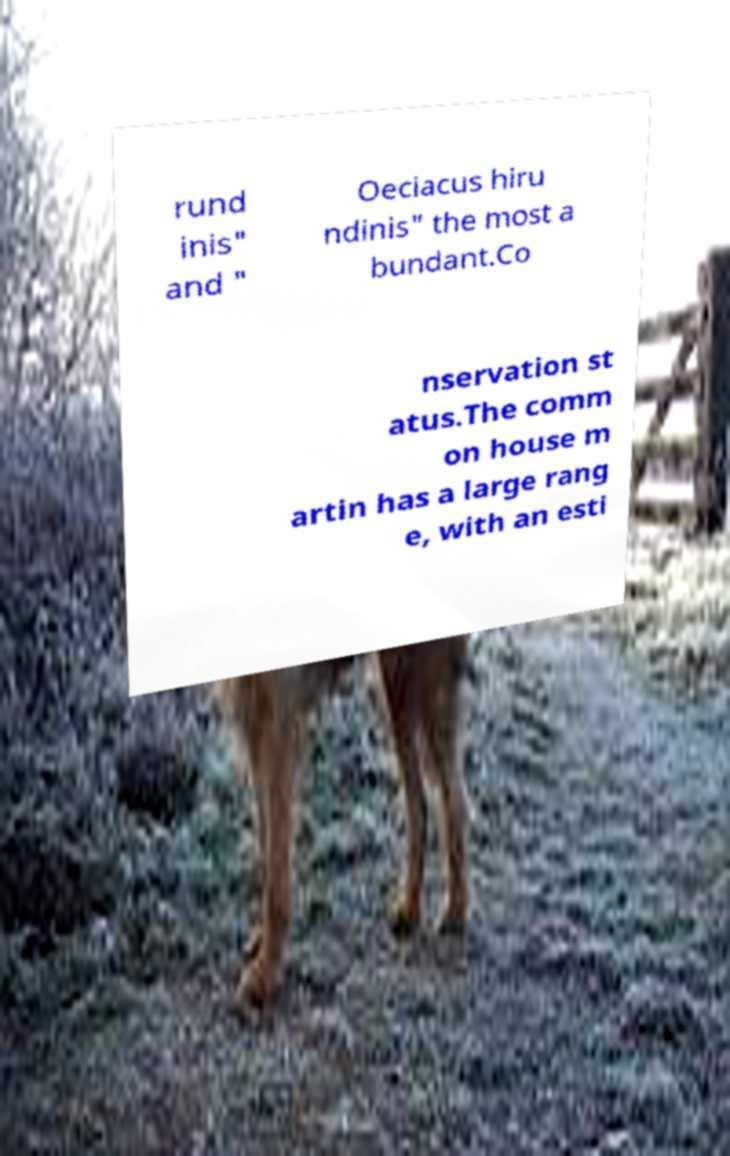Can you read and provide the text displayed in the image?This photo seems to have some interesting text. Can you extract and type it out for me? rund inis" and " Oeciacus hiru ndinis" the most a bundant.Co nservation st atus.The comm on house m artin has a large rang e, with an esti 